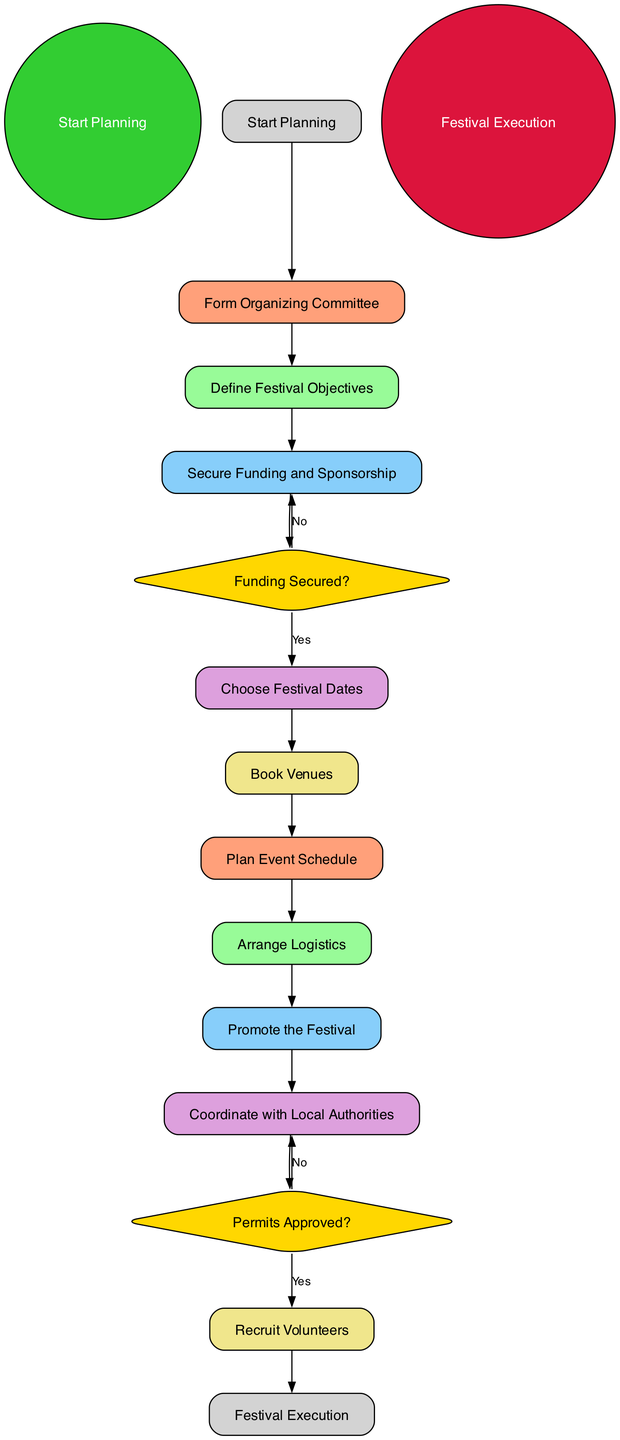What is the initial node in the diagram? The diagram begins with the "Start Planning" node, which is represented at the very beginning as the initial point of the activity flow.
Answer: Start Planning How many activities are there in total? The diagram lists a total of ten activities related to preparing the Gaelic Cultural Festival, indicating various steps necessary for the planning process.
Answer: 10 What is the last step before the festival execution? The final step leading to the "Festival Execution" is "Recruit Volunteers," which gathers local residents to assist with various tasks associated with the event.
Answer: Recruit Volunteers Is there a decision node related to funding? Yes, there is a decision node labeled "Funding Secured?" This node checks if the required budget has been met as part of the planning process.
Answer: Yes What happens if permits are not approved? If the permits are not approved, the flow goes back to "Coordinate with Local Authorities," implying the need to address the issues preventing permit approval before proceeding.
Answer: Coordinate with Local Authorities How does one proceed if funding is secured? If funding is secured, the flow leads to "Choose Festival Dates," which is the next activity in the sequence of organizing the festival.
Answer: Choose Festival Dates What node follows "Arrange Logistics"? The activity that follows "Arrange Logistics" is "Promote the Festival," which involves marketing efforts to attract attendees to the event.
Answer: Promote the Festival What is the shape of the final node? The final node "Festival Execution" is represented in the diagram as a circle, indicating the culmination of all planning efforts in the execution of the festival.
Answer: Circle What is the purpose of the "Define Festival Objectives" activity? The purpose of this activity is to set clear goals for the festival, such as promoting Gaelic culture and attracting tourism to the Isle of Skye.
Answer: Set goals What condition will lead to the "Plan Event Schedule"? The "Plan Event Schedule" activity will occur after "Book Venues," which ensures that appropriate locations are secured before planning the event schedule.
Answer: After "Book Venues" 